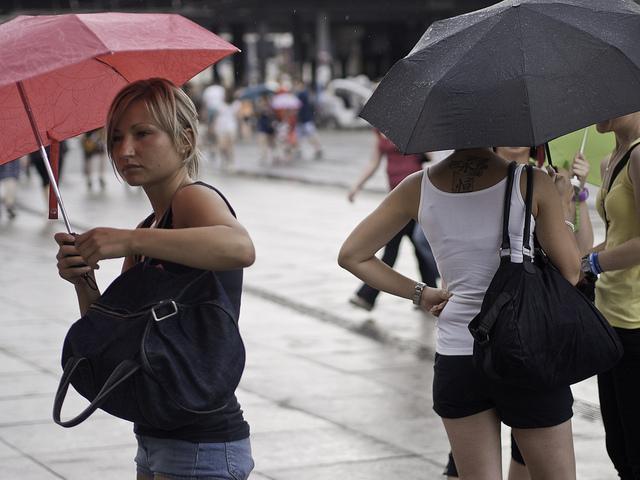How many bracelets is the woman wearing?
Give a very brief answer. 0. How many umbrellas are there?
Give a very brief answer. 2. How many people can you see?
Give a very brief answer. 4. How many umbrellas are in the photo?
Give a very brief answer. 2. How many handbags are in the picture?
Give a very brief answer. 2. 